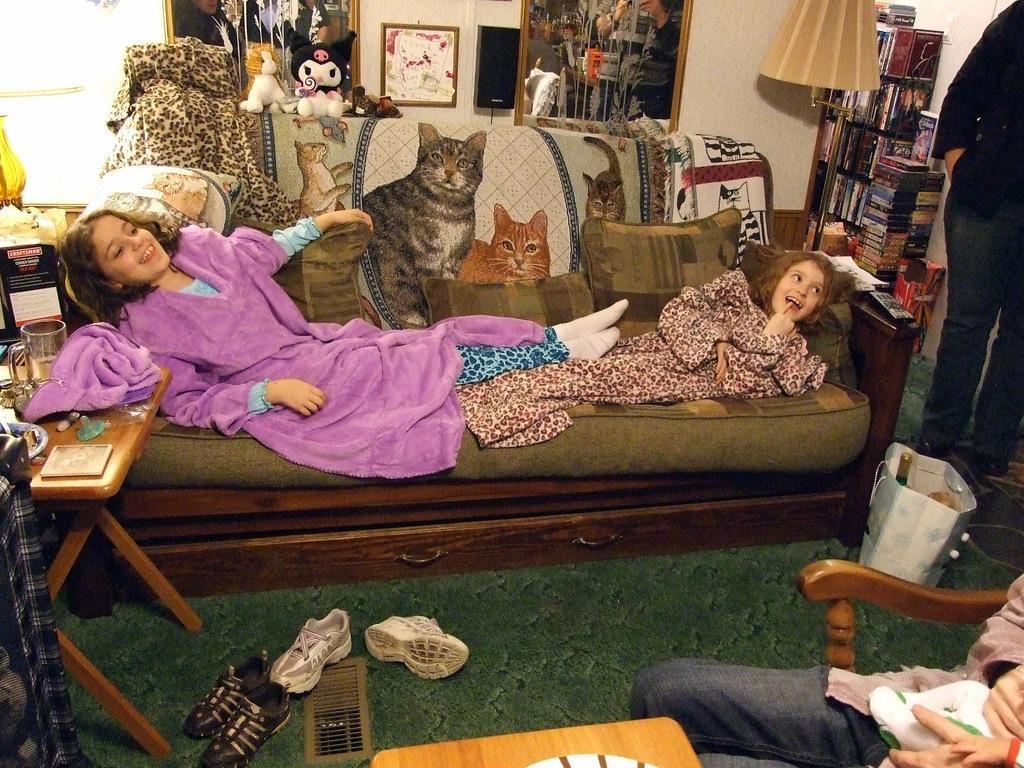Please provide a concise description of this image. This picture is taken inside the room. In this image, in the right corner, we can see a person sitting on the chair. In the middle of the image, we can also see a table. On the left side, we can also see another table, on the table, we can see some clothes, jar and a plate. In the middle of the image, we can see a couch, on the couch, we can see two girls are lying and a mat, clothes. In the background, we can see some books on the shelf, table. On the table, we can see a lamp. In the background, we can also see some toys and a photo frame which is attached to a wall. At the bottom, can see some shoes and a mat. 